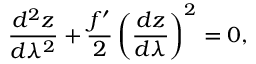Convert formula to latex. <formula><loc_0><loc_0><loc_500><loc_500>\frac { d ^ { 2 } z } { d \lambda ^ { 2 } } + \frac { f ^ { \prime } } { 2 } \left ( \frac { d z } { d \lambda } \right ) ^ { 2 } = 0 ,</formula> 